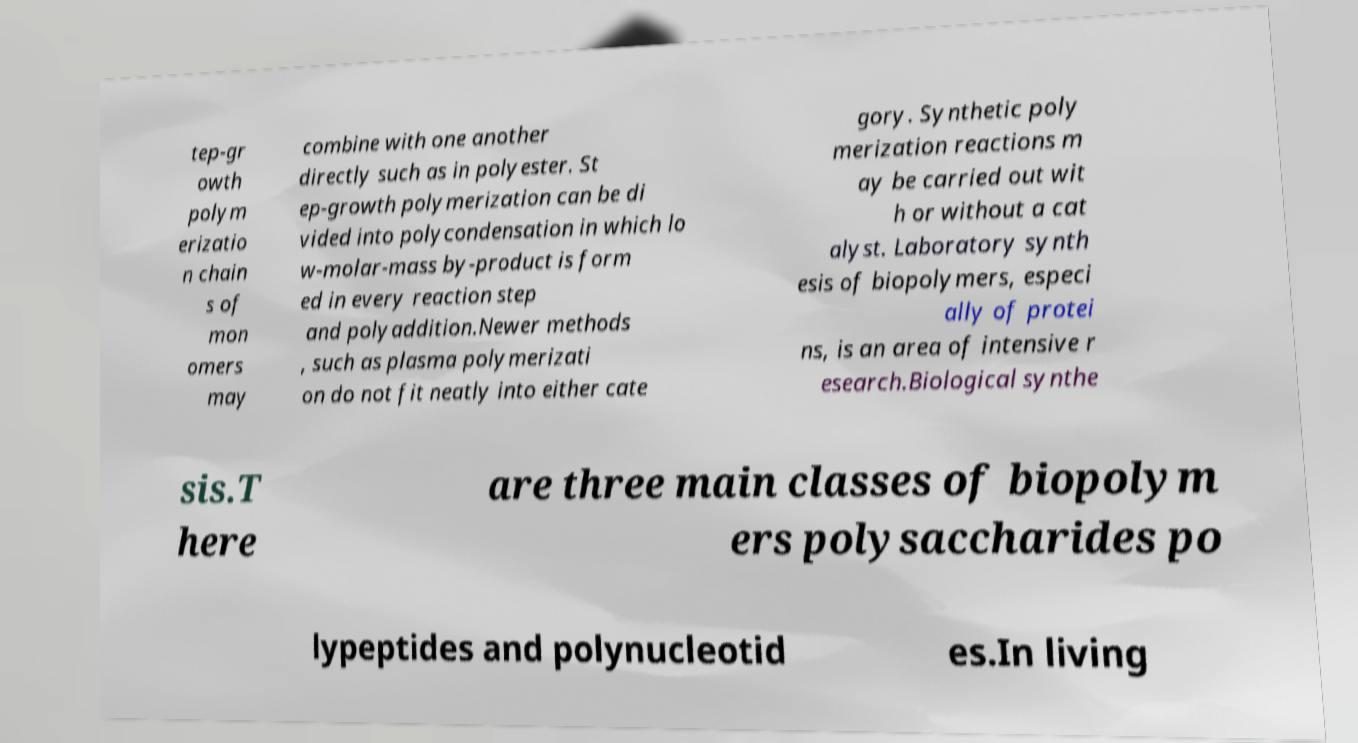What messages or text are displayed in this image? I need them in a readable, typed format. tep-gr owth polym erizatio n chain s of mon omers may combine with one another directly such as in polyester. St ep-growth polymerization can be di vided into polycondensation in which lo w-molar-mass by-product is form ed in every reaction step and polyaddition.Newer methods , such as plasma polymerizati on do not fit neatly into either cate gory. Synthetic poly merization reactions m ay be carried out wit h or without a cat alyst. Laboratory synth esis of biopolymers, especi ally of protei ns, is an area of intensive r esearch.Biological synthe sis.T here are three main classes of biopolym ers polysaccharides po lypeptides and polynucleotid es.In living 